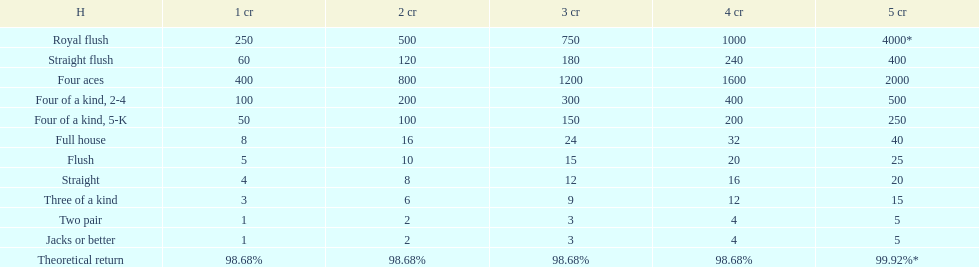Is four 5s worth more or less than four 2s? Less. 